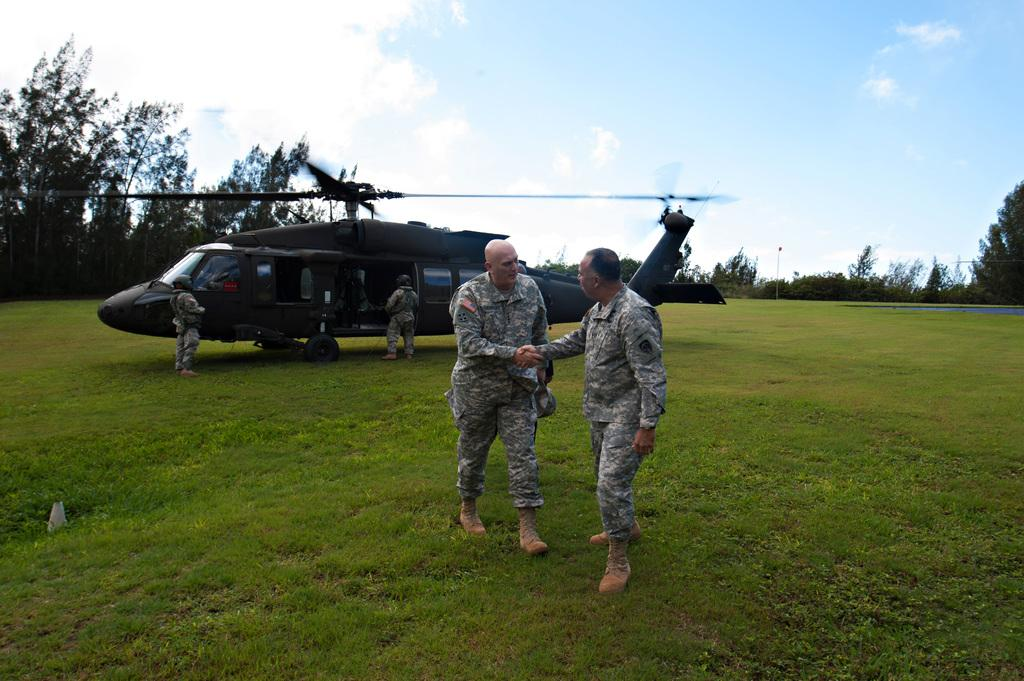Who or what can be seen in the image? There are people in the image. What is located on the ground in the image? There is a helicopter on the ground in the image. What type of natural environment is visible in the background of the image? There are trees in the background of the image. What else can be seen in the background of the image? The sky is visible in the background of the image. What type of ornament is hanging from the helicopter in the image? There is no ornament hanging from the helicopter in the image. Can you tell me how many sticks are being used by the people in the image? There is no indication of sticks being used by the people in the image. 